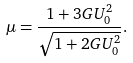<formula> <loc_0><loc_0><loc_500><loc_500>\mu = \frac { 1 + 3 G U _ { 0 } ^ { 2 } } { \sqrt { 1 + 2 G U _ { 0 } ^ { 2 } } } .</formula> 